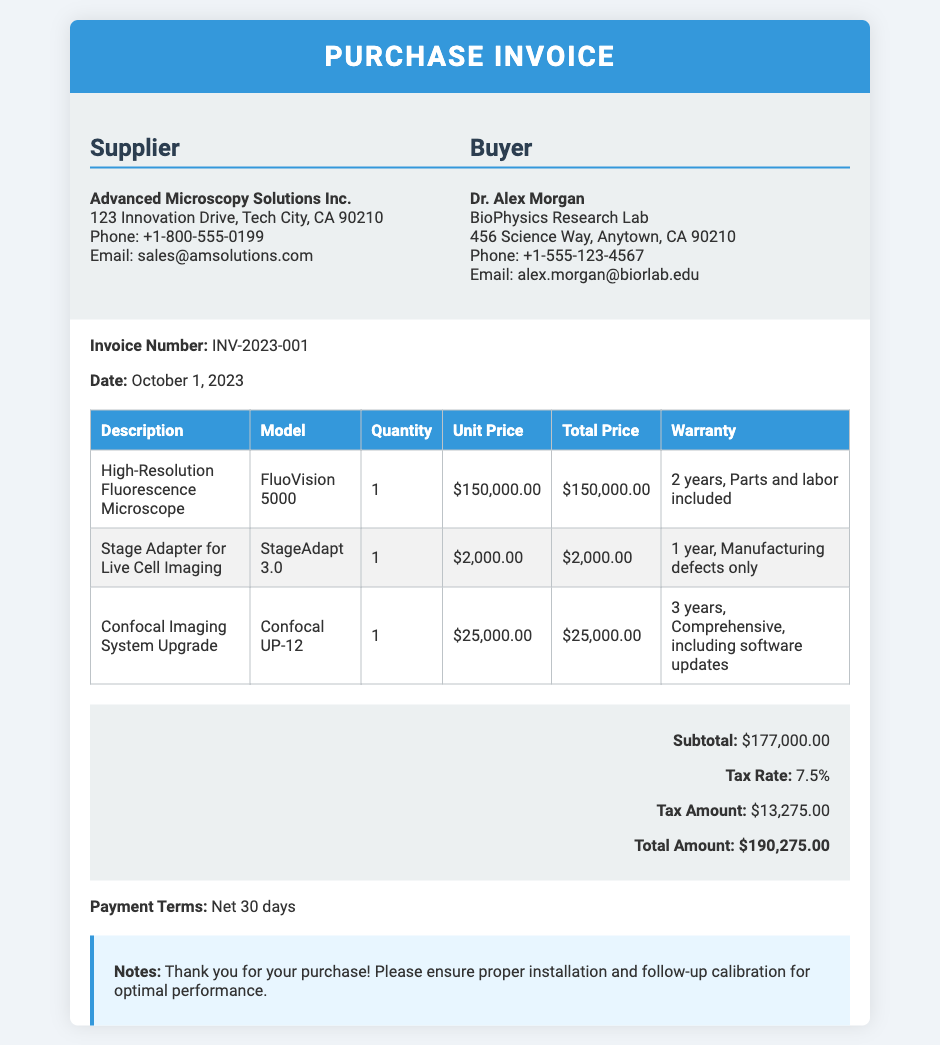What is the invoice number? The invoice number is stated at the top of the document as INV-2023-001.
Answer: INV-2023-001 Who is the supplier? The supplier's name is listed in the document as Advanced Microscopy Solutions Inc.
Answer: Advanced Microscopy Solutions Inc What is the total amount due? The total amount is calculated and mentioned in the total section as $190,275.00.
Answer: $190,275.00 How many years of warranty does the High-Resolution Fluorescence Microscope have? The warranty for the High-Resolution Fluorescence Microscope is provided as 2 years, including parts and labor.
Answer: 2 years What is the subtotal before tax? The subtotal, which is the sum of item costs before tax, is specified as $177,000.00.
Answer: $177,000.00 What is the tax rate applied to the purchase? The document states the tax rate applied as 7.5%.
Answer: 7.5% How many items were purchased in total? The document lists three items in the items table.
Answer: 3 What is the payment term specified in the invoice? The payment term is outlined in the document as Net 30 days.
Answer: Net 30 days What type of microscope is listed first in the purchase? The first item in the items table is identified as the High-Resolution Fluorescence Microscope.
Answer: High-Resolution Fluorescence Microscope 